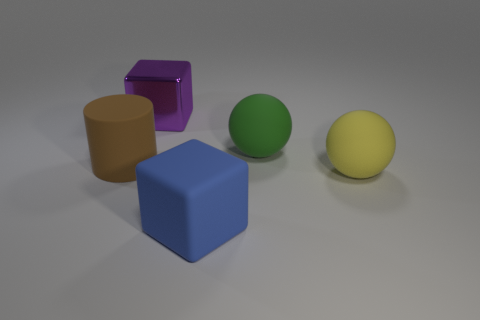Is there anything else that has the same material as the big purple block?
Your answer should be very brief. No. Is there anything else that is the same color as the metallic block?
Make the answer very short. No. Are there more large yellow matte things in front of the brown object than big yellow objects that are on the right side of the big green ball?
Make the answer very short. No. How many other cyan cylinders have the same size as the rubber cylinder?
Keep it short and to the point. 0. Are there fewer yellow balls that are behind the large brown cylinder than balls in front of the green sphere?
Provide a short and direct response. Yes. Is there a green object of the same shape as the brown object?
Provide a short and direct response. No. Is the purple shiny object the same shape as the brown matte thing?
Offer a terse response. No. How many large things are either brown matte cylinders or blue shiny blocks?
Your response must be concise. 1. Are there more green balls than big blocks?
Offer a very short reply. No. Do the brown cylinder behind the big matte block and the blue matte thing that is right of the large purple object have the same size?
Keep it short and to the point. Yes. 